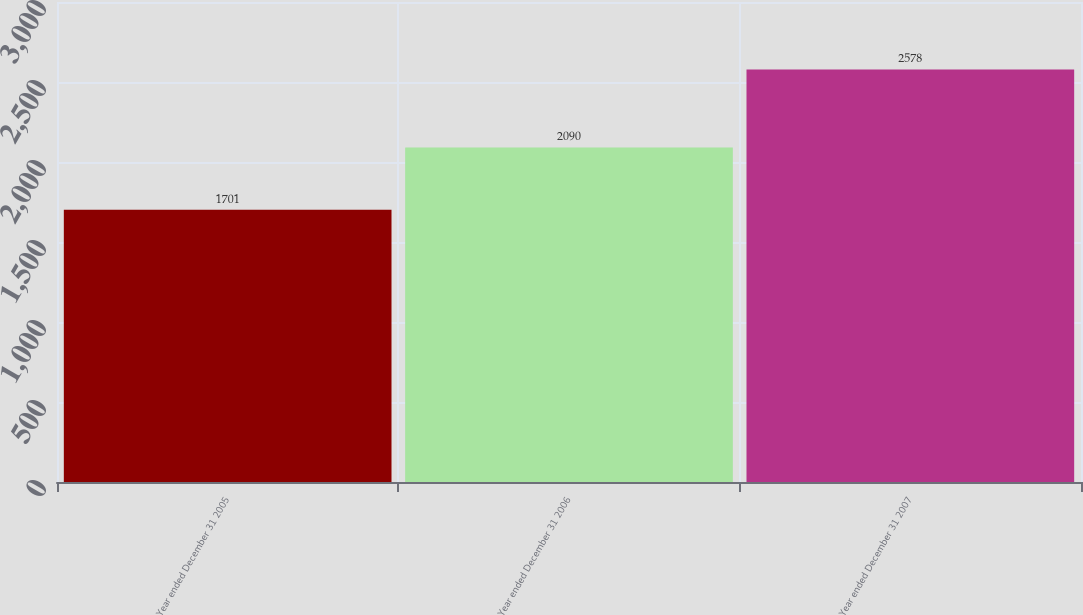<chart> <loc_0><loc_0><loc_500><loc_500><bar_chart><fcel>Year ended December 31 2005<fcel>Year ended December 31 2006<fcel>Year ended December 31 2007<nl><fcel>1701<fcel>2090<fcel>2578<nl></chart> 